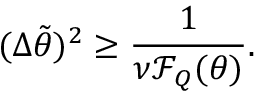Convert formula to latex. <formula><loc_0><loc_0><loc_500><loc_500>( \Delta \tilde { \theta } ) ^ { 2 } \geq \frac { 1 } { \nu \mathcal { F } _ { Q } ( \theta ) } .</formula> 